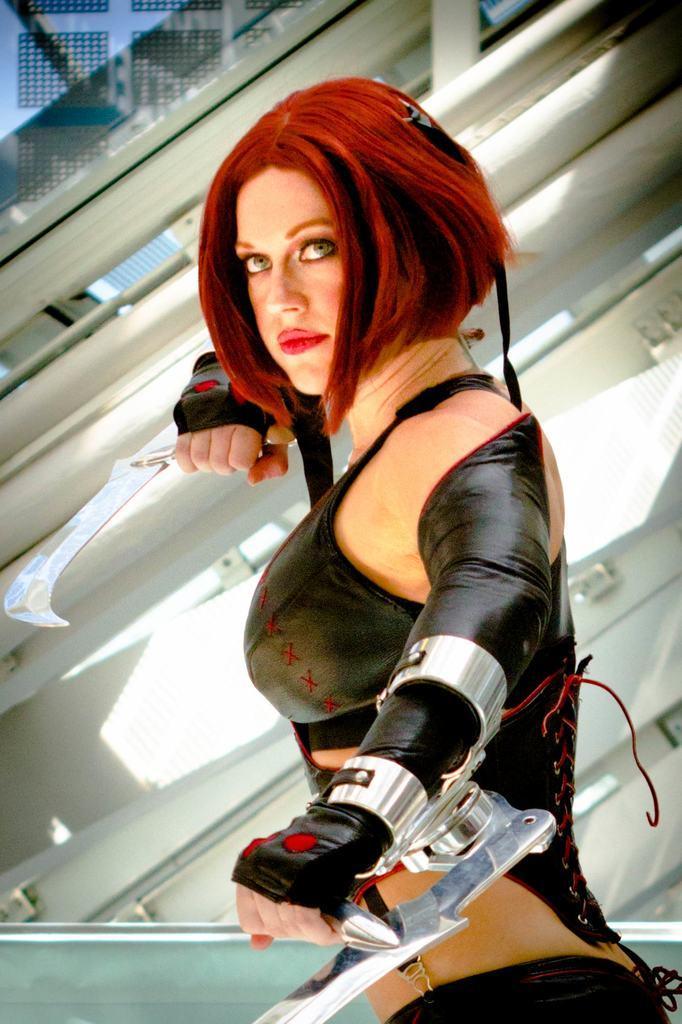Can you describe this image briefly? In the middle of the image a woman is standing and holding knives. Behind her there is wall. 